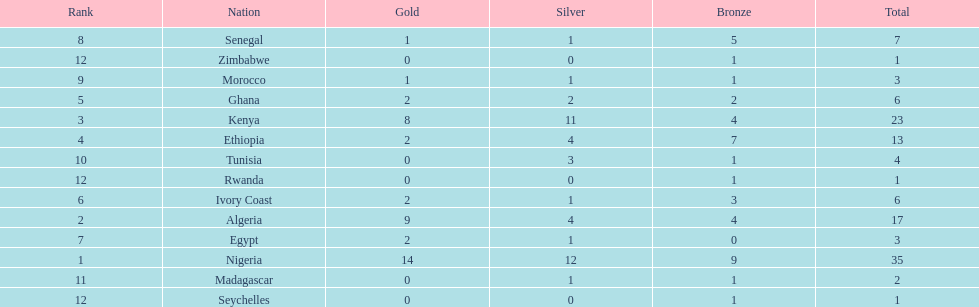What are all the nations? Nigeria, Algeria, Kenya, Ethiopia, Ghana, Ivory Coast, Egypt, Senegal, Morocco, Tunisia, Madagascar, Rwanda, Zimbabwe, Seychelles. How many bronze medals did they win? 9, 4, 4, 7, 2, 3, 0, 5, 1, 1, 1, 1, 1, 1. And which nation did not win one? Egypt. 